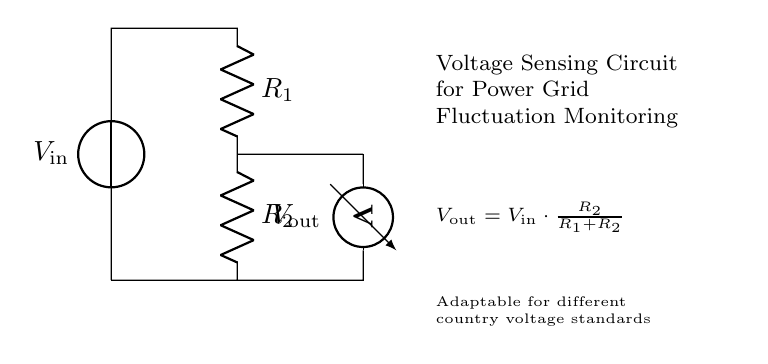What is the input voltage of this circuit? The input voltage, denoted as V_in in the circuit diagram, is the voltage that is supplied to the voltage divider circuit. The diagram does not specify an actual value but rather indicates its presence.
Answer: V_in What are the resistances in this circuit? The circuit includes two resistors labeled R_1 and R_2. The values for these resistors are not specified in the diagram, but they are essential to the operation of the voltage divider.
Answer: R_1, R_2 What is the expression for the output voltage? The output voltage, denoted as V_out, is expressed in the diagram as V_out = V_in * (R_2 / (R_1 + R_2)). This formula is derived from the principle of a voltage divider, which divides the input voltage based on the resistance values.
Answer: V_out = V_in * (R_2 / (R_1 + R_2)) How does the output voltage relate to the input voltage? The output voltage V_out is a fraction of the input voltage V_in based on the relative values of R_1 and R_2. The formula informs us that V_out decreases as R_1 increases or R_2 decreases, providing insight into how the circuit scales the input voltage.
Answer: It is a fraction Why is this circuit adaptable for different country voltage standards? The circuit is adaptable due to the adjustable values of R_1 and R_2, allowing it to be configured to match varying input voltage levels across different countries. This customization enables compliance with local electrical standards.
Answer: Adjustable resistors What is the purpose of the voltmeter in the circuit? The voltmeter is used to measure the output voltage V_out, providing the user with an indication of the voltage level after it has been divided by the resistors in the circuit. This measurement is crucial for monitoring power grid fluctuations.
Answer: Measure V_out 